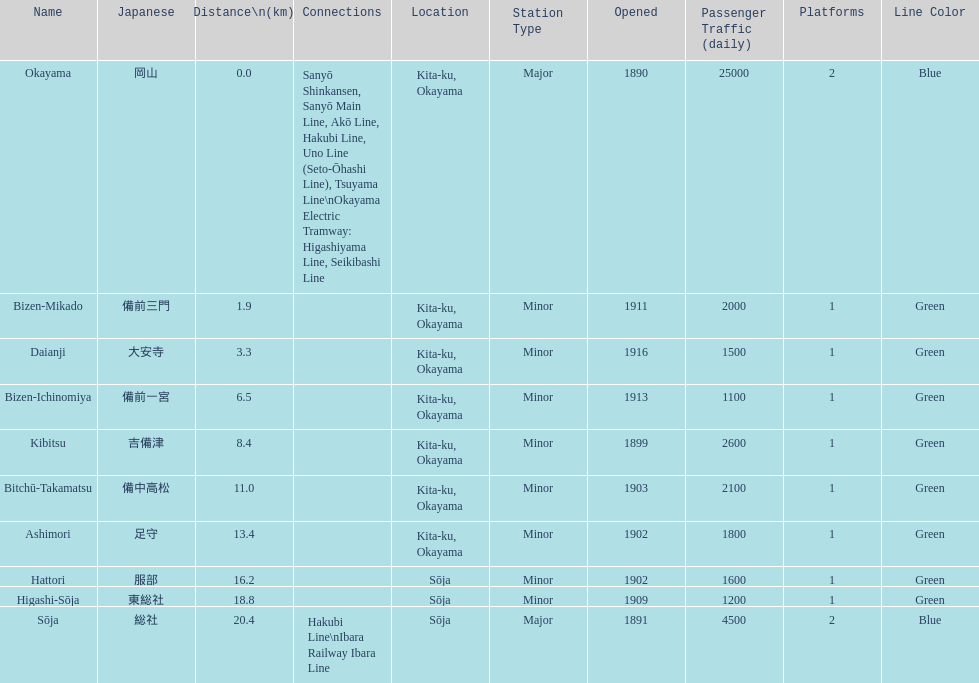Which has the most distance, hattori or kibitsu? Hattori. 